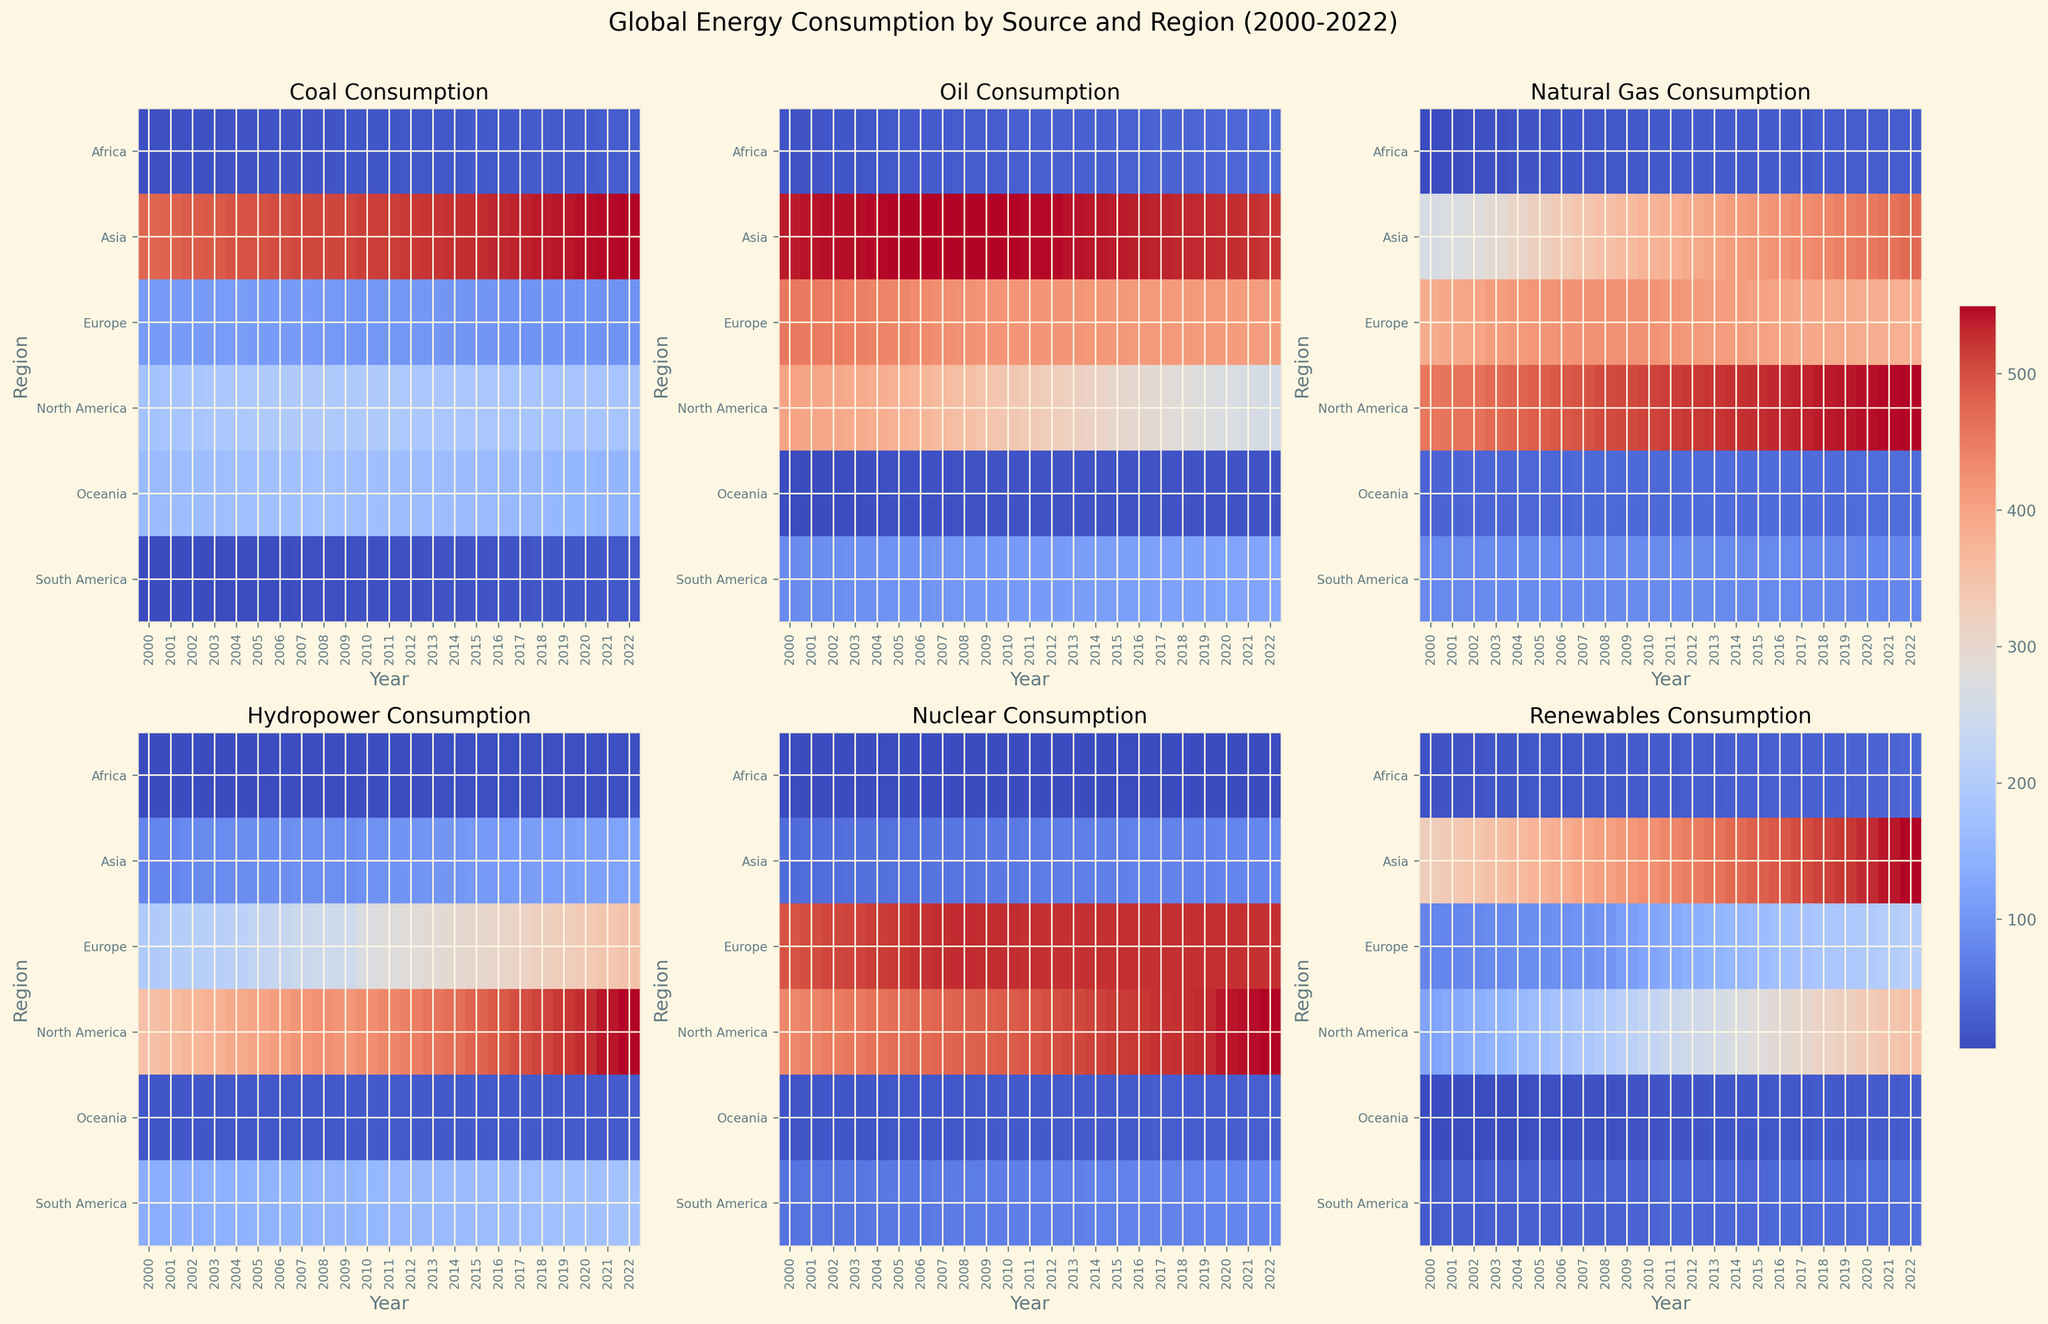Which region had the highest coal consumption in 2000? By looking at the heatmap panel for Coal Consumption in 2000, observe the color intensity corresponding to each region. The darkest shade indicates the highest value, which is Asia.
Answer: Asia How does the oil consumption in North America compare to Europe in 2012? By checking the heatmap panel for Oil Consumption in 2012 and comparing the color intensities for North America and Europe, North America shows a darker shade than Europe, indicating higher consumption.
Answer: North America has higher oil consumption than Europe in 2012 What is the average hydropower consumption in South America from 2000 to 2022? For each year from 2000 to 2022, note the color intensity in the Hydropower Consumption panel for South America. The average color intensity indicates the average consumption over these years. Visually, the shades are relatively consistent, suggesting an approximate average. However, pulling precise average values requires exact numerical analysis.
Answer: Approximately constant, but requires numerical confirmation Which region shows the greatest increase in renewable energy consumption from 2000 to 2022? By examining the Renewable Energy panel, observe how the color intensity changed from 2000 to 2022 for each region. The region with the most significant change in shade indicates the greatest increase, which is Asia.
Answer: Asia What is the trend of nuclear consumption in Europe from 2000 to 2022? In the Nuclear Consumption panel, trace the changing color intensity for Europe from 2000 to 2022. The relatively consistent color shade indicates stable consumption over these years.
Answer: Relatively stable Compare the natural gas consumption trends between North America and Asia from 2000 to 2022. By looking at the Natural Gas Consumption panel from 2000 to 2022, observe the color changes for both North America and Asia. North America shows a consistent intensity, whereas Asia shows a gradual darkening, indicating an increase in consumption.
Answer: Asia's consumption increased, while North America's remained stable What was the lowest coal consumption region in 2007? By looking at the Coal Consumption panel for 2007, identify the region with the lightest color shade. The lightest shade corresponds to Africa, indicating the lowest consumption.
Answer: Africa Determine the region with the highest renewable energy consumption in 2022. By checking the Renewable Energy panel for the year 2022, the darkest shade represents the highest consumption. Asia has the most intense color, indicating the highest consumption.
Answer: Asia Estimate the overall trend of oil consumption in Oceania from 2000 to 2022. In the Oil Consumption panel, trace the color intensity for Oceania across the years. The color gradually darkens, indicating a slight increase in oil consumption.
Answer: Increasing Is the trend of hydropower consumption in Africa upward or downward from 2000 to 2022? By inspecting the Hydropower panel for Africa, the colors remain consistently light, indicating that there is no substantial increase or decrease in consumption.
Answer: Stable 